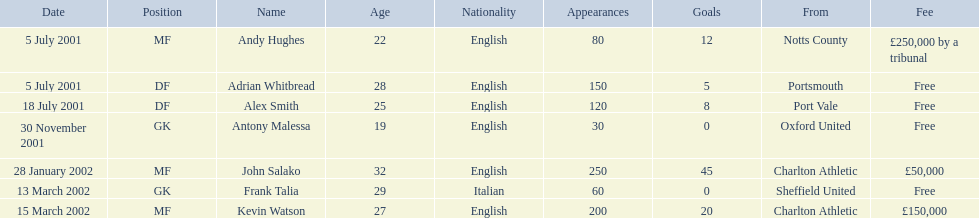Who were all the players? Andy Hughes, Adrian Whitbread, Alex Smith, Antony Malessa, John Salako, Frank Talia, Kevin Watson. What were the transfer fees of these players? £250,000 by a tribunal, Free, Free, Free, £50,000, Free, £150,000. Of these, which belong to andy hughes and john salako? £250,000 by a tribunal, £50,000. Of these, which is larger? £250,000 by a tribunal. Which player commanded this fee? Andy Hughes. 